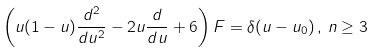<formula> <loc_0><loc_0><loc_500><loc_500>\left ( u ( 1 - u ) \frac { d ^ { 2 } } { d u ^ { 2 } } - 2 u \frac { d } { d u } + 6 \right ) F = \delta ( u - u _ { 0 } ) \, , \, n \geq 3</formula> 